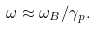Convert formula to latex. <formula><loc_0><loc_0><loc_500><loc_500>\omega \approx { \omega _ { B } / \gamma _ { p } } .</formula> 